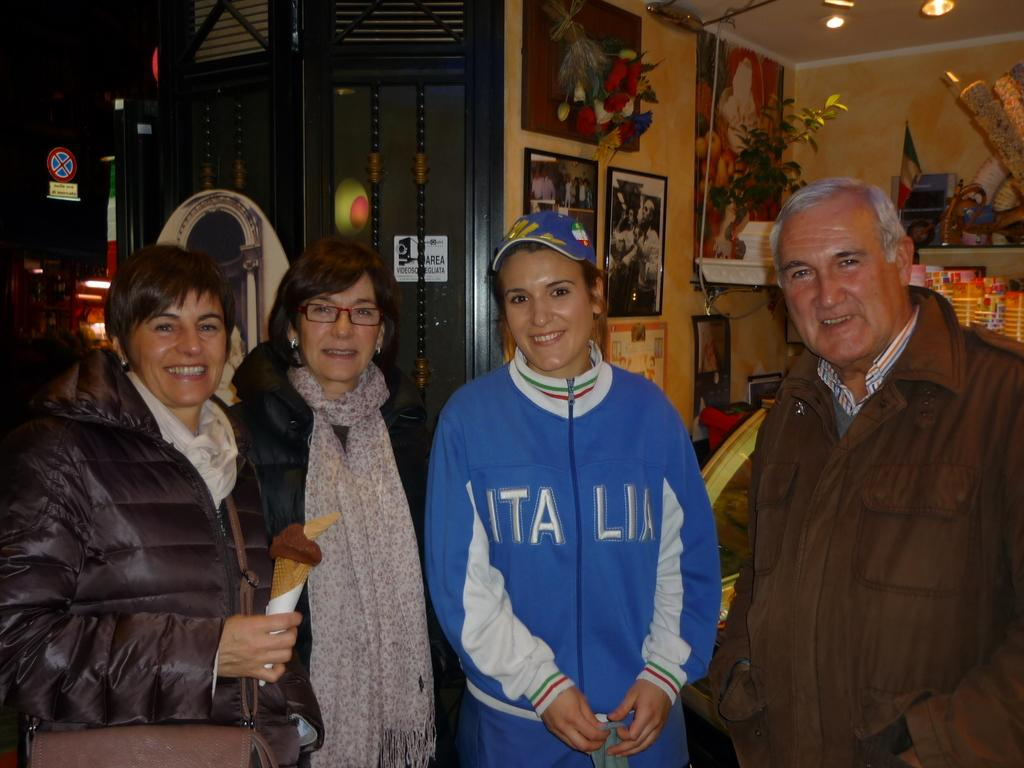Provide a one-sentence caption for the provided image. A woman with a blue Italia sweatshirt standing in a group of 4 people. 